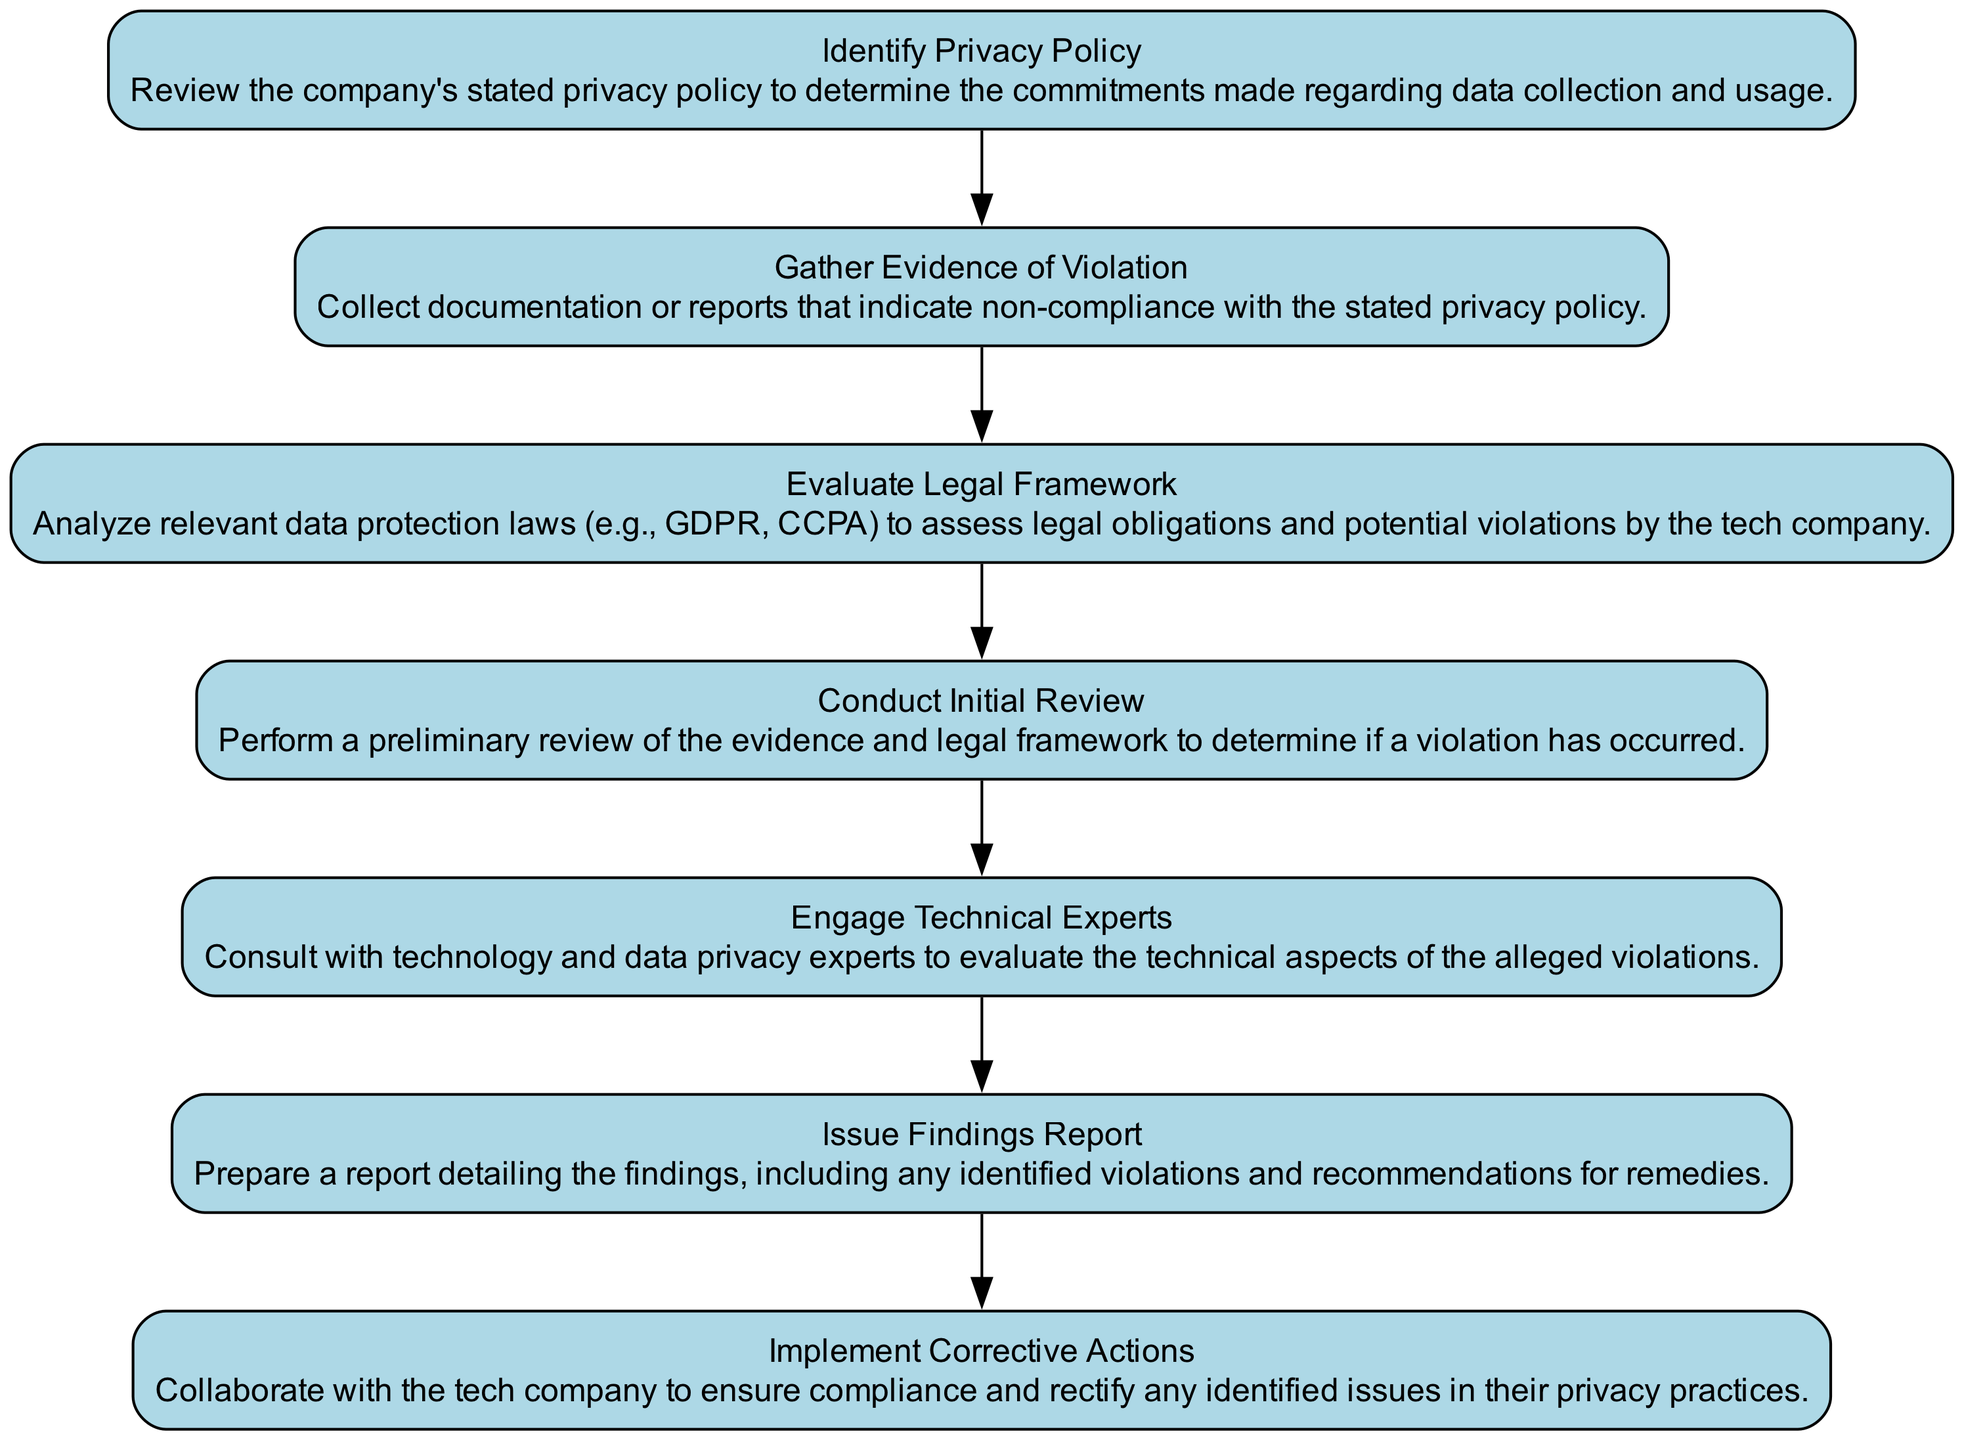What is the first step in the process? The first step in the process is "Identify Privacy Policy." This is derived from the arrangement of the nodes in the flow chart, where the first node contains that specific information.
Answer: Identify Privacy Policy How many steps are there in total? By counting all the nodes present in the flow chart, there are seven distinct steps identified.
Answer: 7 What is the last step listed? The last step in the diagram is "Implement Corrective Actions." This can be seen by examining the structure of the flow chart and locating the final node.
Answer: Implement Corrective Actions Which step follows "Evaluate Legal Framework"? After "Evaluate Legal Framework," the next step is "Conduct Initial Review." This follows the flow from the evaluated step and leads sequentially to the next node.
Answer: Conduct Initial Review What type of experts are engaged in the process? The process involves "Technical Experts," as indicated in the specific step dedicated to this engagement within the diagram.
Answer: Technical Experts How does the initial review relate to evidence of violation? The "Conduct Initial Review" step comes after "Gather Evidence of Violation," which signifies that the review is based on the collected evidence. This establishes a direct connection where one step depends on the previous evidence gathering.
Answer: Based on gathered evidence What document is prepared after the investigations? Following the investigations, the step is to "Issue Findings Report," which indicates the formal documentation created to summarize the outcomes of the review.
Answer: Issue Findings Report What is the main purpose of engaging technical experts? The main purpose is to "evaluate the technical aspects" of the alleged violations, indicating a specialized examination of evidence using technical expertise.
Answer: Evaluate the technical aspects How many edges connect the nodes in this diagram? Each step is connected sequentially, leading to a total of six edges that connect all seven nodes, as each node links to the next in the flow process.
Answer: 6 